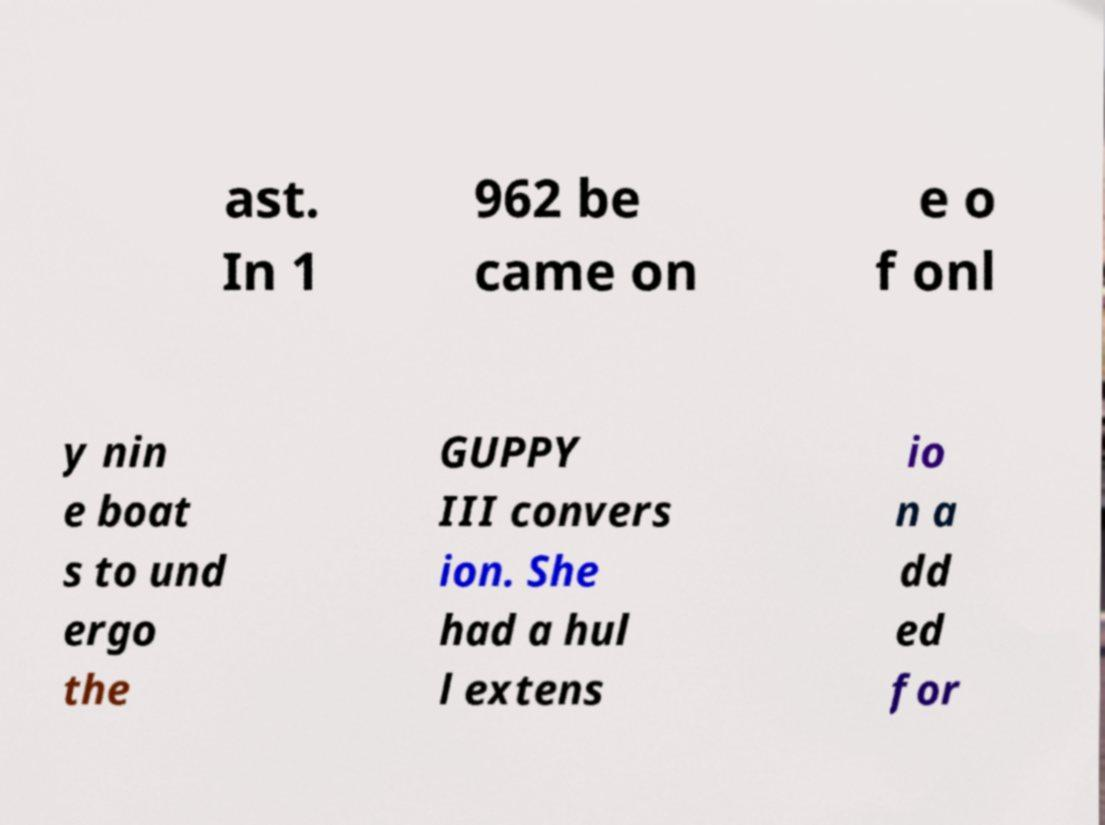There's text embedded in this image that I need extracted. Can you transcribe it verbatim? ast. In 1 962 be came on e o f onl y nin e boat s to und ergo the GUPPY III convers ion. She had a hul l extens io n a dd ed for 